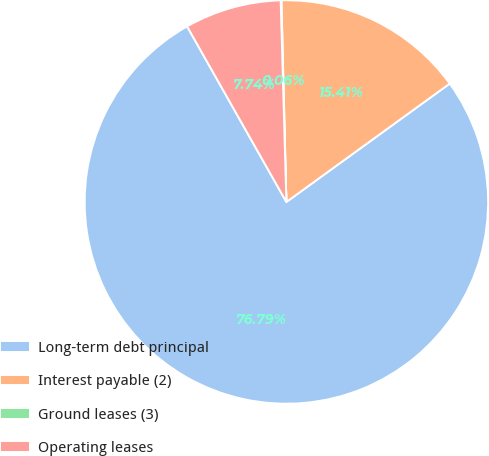Convert chart. <chart><loc_0><loc_0><loc_500><loc_500><pie_chart><fcel>Long-term debt principal<fcel>Interest payable (2)<fcel>Ground leases (3)<fcel>Operating leases<nl><fcel>76.79%<fcel>15.41%<fcel>0.06%<fcel>7.74%<nl></chart> 